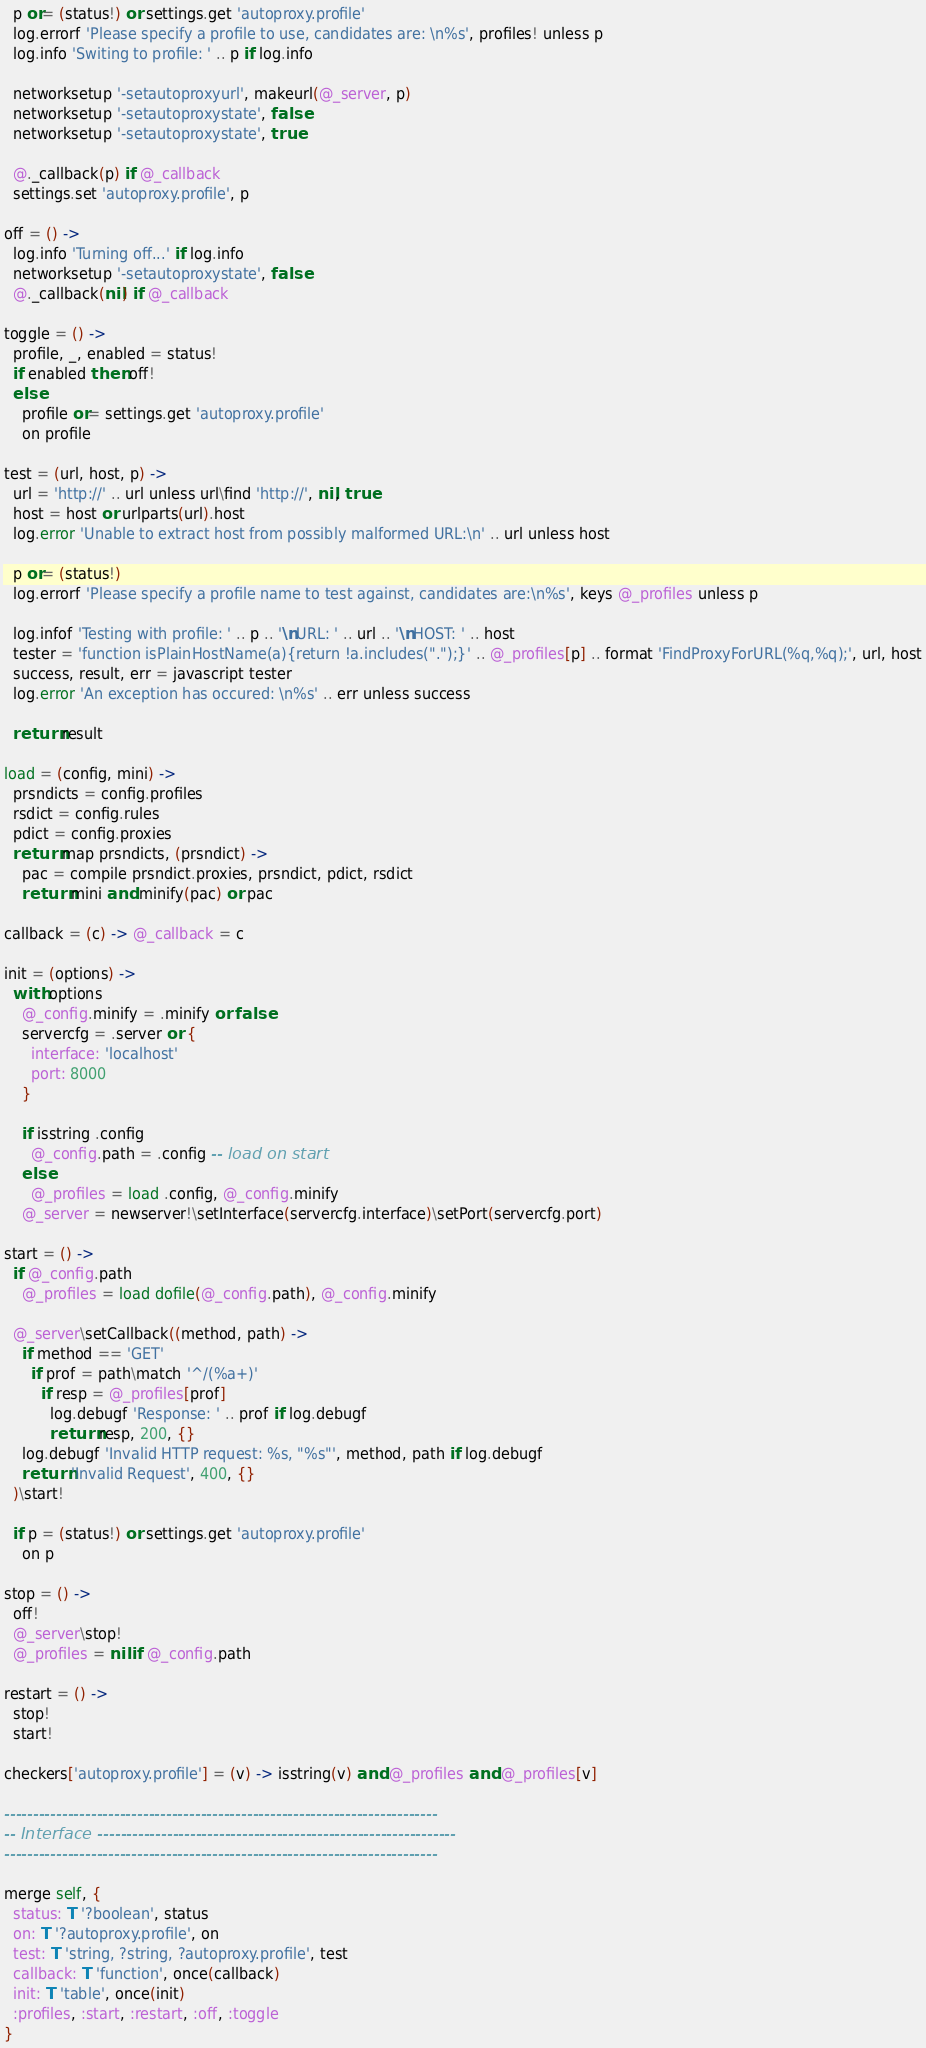Convert code to text. <code><loc_0><loc_0><loc_500><loc_500><_MoonScript_>  p or= (status!) or settings.get 'autoproxy.profile'
  log.errorf 'Please specify a profile to use, candidates are: \n%s', profiles! unless p
  log.info 'Switing to profile: ' .. p if log.info

  networksetup '-setautoproxyurl', makeurl(@_server, p)
  networksetup '-setautoproxystate', false
  networksetup '-setautoproxystate', true

  @._callback(p) if @_callback
  settings.set 'autoproxy.profile', p

off = () ->
  log.info 'Turning off...' if log.info
  networksetup '-setautoproxystate', false
  @._callback(nil) if @_callback

toggle = () ->
  profile, _, enabled = status!
  if enabled then off!
  else
    profile or= settings.get 'autoproxy.profile'
    on profile

test = (url, host, p) ->
  url = 'http://' .. url unless url\find 'http://', nil, true
  host = host or urlparts(url).host
  log.error 'Unable to extract host from possibly malformed URL:\n' .. url unless host

  p or= (status!)
  log.errorf 'Please specify a profile name to test against, candidates are:\n%s', keys @_profiles unless p

  log.infof 'Testing with profile: ' .. p .. '\nURL: ' .. url .. '\nHOST: ' .. host
  tester = 'function isPlainHostName(a){return !a.includes(".");}' .. @_profiles[p] .. format 'FindProxyForURL(%q,%q);', url, host
  success, result, err = javascript tester
  log.error 'An exception has occured: \n%s' .. err unless success

  return result

load = (config, mini) ->
  prsndicts = config.profiles
  rsdict = config.rules
  pdict = config.proxies
  return map prsndicts, (prsndict) ->
    pac = compile prsndict.proxies, prsndict, pdict, rsdict
    return mini and minify(pac) or pac

callback = (c) -> @_callback = c

init = (options) ->
  with options
    @_config.minify = .minify or false
    servercfg = .server or {
      interface: 'localhost'
      port: 8000
    }

    if isstring .config
      @_config.path = .config -- load on start
    else
      @_profiles = load .config, @_config.minify
    @_server = newserver!\setInterface(servercfg.interface)\setPort(servercfg.port)

start = () ->
  if @_config.path
    @_profiles = load dofile(@_config.path), @_config.minify

  @_server\setCallback((method, path) ->
    if method == 'GET'
      if prof = path\match '^/(%a+)'
        if resp = @_profiles[prof]
          log.debugf 'Response: ' .. prof if log.debugf
          return resp, 200, {}
    log.debugf 'Invalid HTTP request: %s, "%s"', method, path if log.debugf
    return 'Invalid Request', 400, {}
  )\start!

  if p = (status!) or settings.get 'autoproxy.profile'
    on p

stop = () ->
  off!
  @_server\stop!
  @_profiles = nil if @_config.path

restart = () ->
  stop!
  start!

checkers['autoproxy.profile'] = (v) -> isstring(v) and @_profiles and @_profiles[v]

---------------------------------------------------------------------------
-- Interface --------------------------------------------------------------
---------------------------------------------------------------------------

merge self, {
  status: T '?boolean', status
  on: T '?autoproxy.profile', on
  test: T 'string, ?string, ?autoproxy.profile', test
  callback: T 'function', once(callback)
  init: T 'table', once(init)
  :profiles, :start, :restart, :off, :toggle
}
</code> 